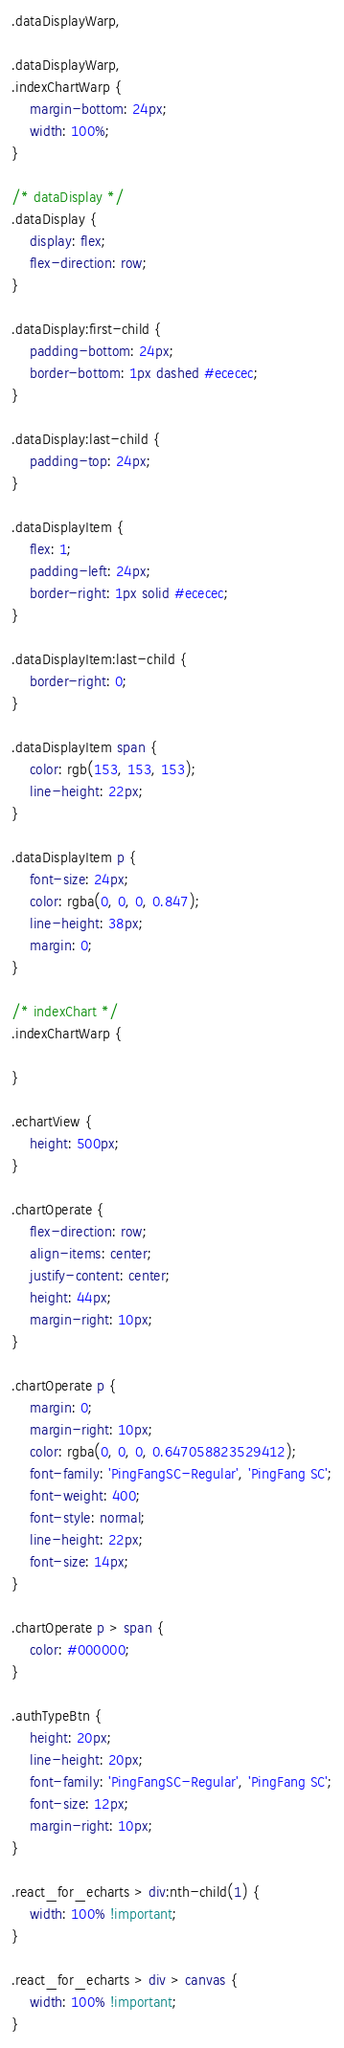<code> <loc_0><loc_0><loc_500><loc_500><_CSS_>.dataDisplayWarp,

.dataDisplayWarp,
.indexChartWarp {
    margin-bottom: 24px;
    width: 100%;
}

/* dataDisplay */
.dataDisplay {
    display: flex;
    flex-direction: row;
}

.dataDisplay:first-child {
    padding-bottom: 24px;
    border-bottom: 1px dashed #ececec;
}

.dataDisplay:last-child {
    padding-top: 24px;
}

.dataDisplayItem {
    flex: 1;
    padding-left: 24px;
    border-right: 1px solid #ececec;
}

.dataDisplayItem:last-child {
    border-right: 0;
}

.dataDisplayItem span {
    color: rgb(153, 153, 153);
    line-height: 22px;
}

.dataDisplayItem p {
    font-size: 24px;
    color: rgba(0, 0, 0, 0.847);
    line-height: 38px;
    margin: 0;
}

/* indexChart */
.indexChartWarp {

}

.echartView {
    height: 500px;
}

.chartOperate {
    flex-direction: row;
    align-items: center;
    justify-content: center;
    height: 44px;
    margin-right: 10px;
}

.chartOperate p {
    margin: 0;
    margin-right: 10px;
    color: rgba(0, 0, 0, 0.647058823529412);
    font-family: 'PingFangSC-Regular', 'PingFang SC';
    font-weight: 400;
    font-style: normal;
    line-height: 22px;
    font-size: 14px;
}

.chartOperate p > span {
    color: #000000;
}

.authTypeBtn {
    height: 20px;
    line-height: 20px;
    font-family: 'PingFangSC-Regular', 'PingFang SC';
    font-size: 12px;
    margin-right: 10px;
}

.react_for_echarts > div:nth-child(1) {
    width: 100% !important;
}

.react_for_echarts > div > canvas {
    width: 100% !important;
}
</code> 